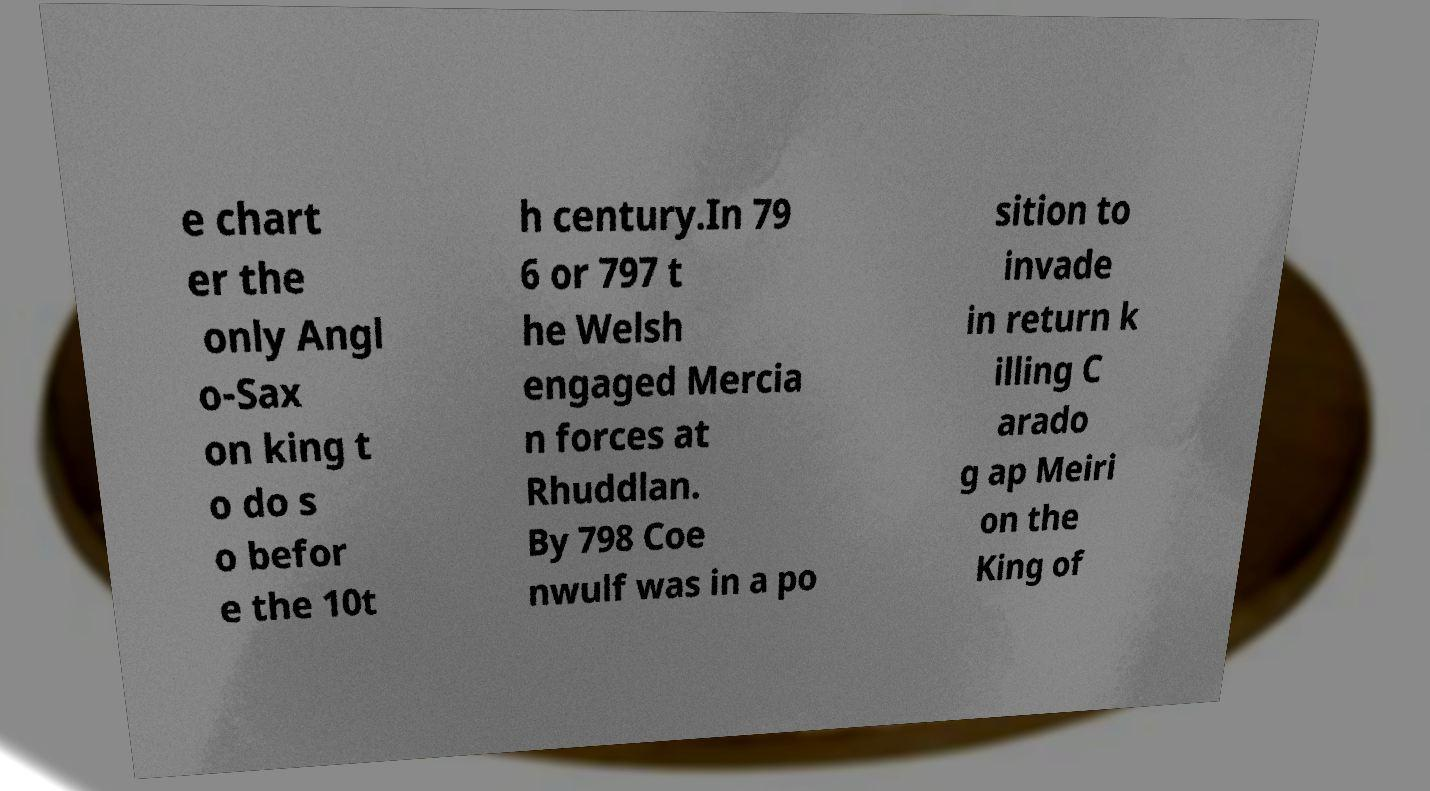Can you read and provide the text displayed in the image?This photo seems to have some interesting text. Can you extract and type it out for me? e chart er the only Angl o-Sax on king t o do s o befor e the 10t h century.In 79 6 or 797 t he Welsh engaged Mercia n forces at Rhuddlan. By 798 Coe nwulf was in a po sition to invade in return k illing C arado g ap Meiri on the King of 